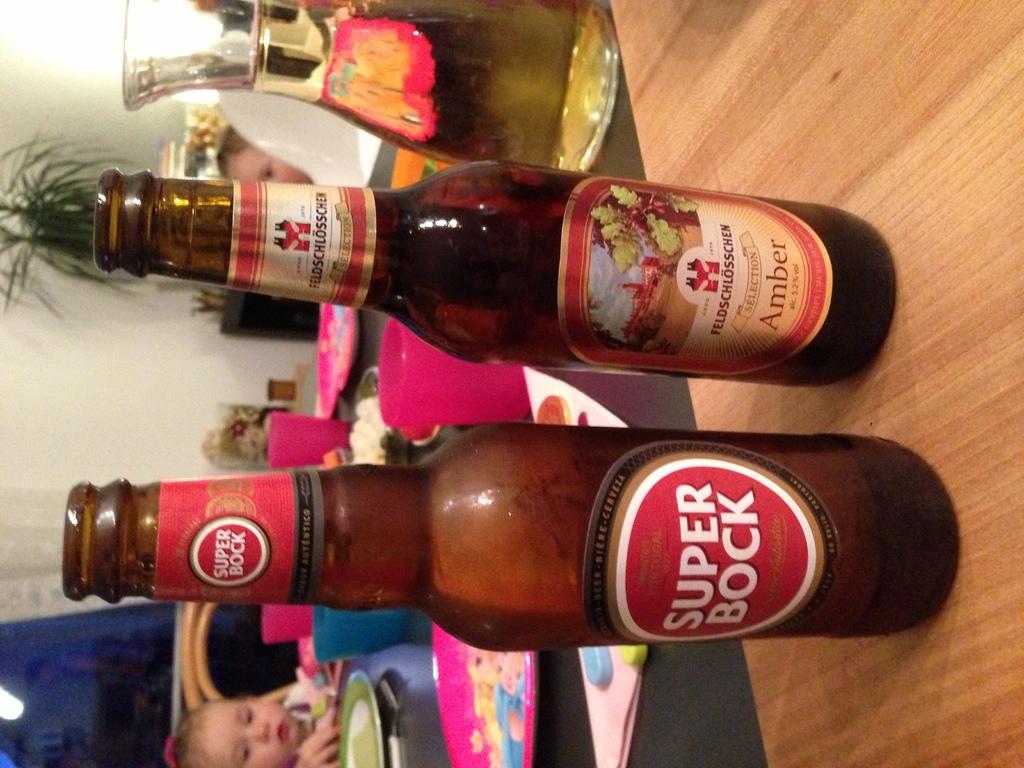The beer is not a regular bock, what type of bock is it?
Your response must be concise. Super. What color of beer is in the bottle that is further away?
Your response must be concise. Amber. 